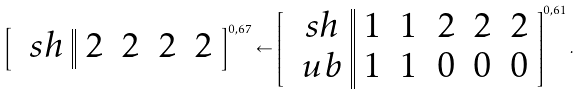<formula> <loc_0><loc_0><loc_500><loc_500>\left [ \begin{array} { c | | c c c c } \ s h & 2 & 2 & 2 & 2 \end{array} \right ] ^ { 0 , 6 7 } \leftarrow \left [ \begin{array} { c | | c c c c c } \ s h & 1 & 1 & 2 & 2 & 2 \\ \ u b & 1 & 1 & 0 & 0 & 0 \end{array} \right ] ^ { 0 , 6 1 } .</formula> 